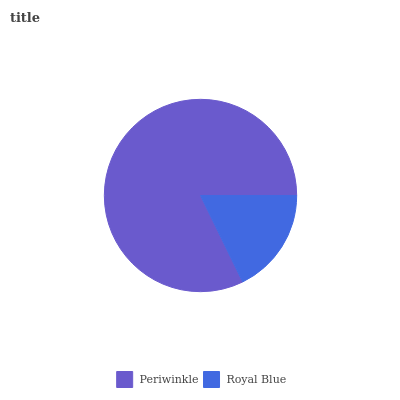Is Royal Blue the minimum?
Answer yes or no. Yes. Is Periwinkle the maximum?
Answer yes or no. Yes. Is Royal Blue the maximum?
Answer yes or no. No. Is Periwinkle greater than Royal Blue?
Answer yes or no. Yes. Is Royal Blue less than Periwinkle?
Answer yes or no. Yes. Is Royal Blue greater than Periwinkle?
Answer yes or no. No. Is Periwinkle less than Royal Blue?
Answer yes or no. No. Is Periwinkle the high median?
Answer yes or no. Yes. Is Royal Blue the low median?
Answer yes or no. Yes. Is Royal Blue the high median?
Answer yes or no. No. Is Periwinkle the low median?
Answer yes or no. No. 